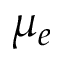<formula> <loc_0><loc_0><loc_500><loc_500>\mu _ { e }</formula> 